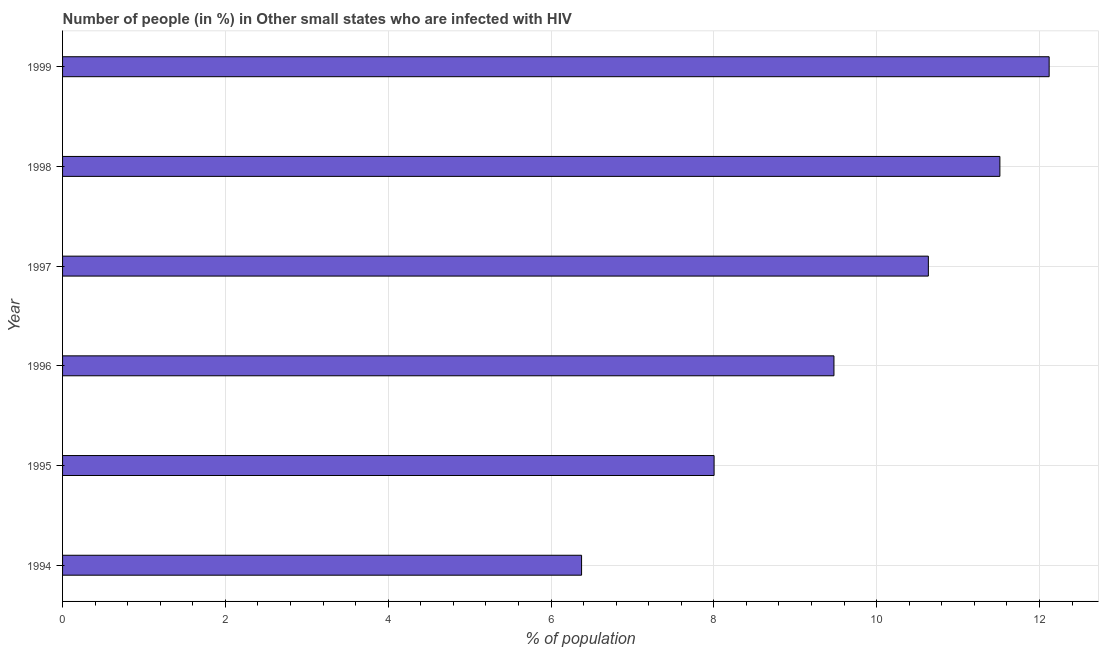Does the graph contain any zero values?
Provide a short and direct response. No. What is the title of the graph?
Keep it short and to the point. Number of people (in %) in Other small states who are infected with HIV. What is the label or title of the X-axis?
Your response must be concise. % of population. What is the label or title of the Y-axis?
Offer a terse response. Year. What is the number of people infected with hiv in 1996?
Offer a very short reply. 9.48. Across all years, what is the maximum number of people infected with hiv?
Your answer should be very brief. 12.12. Across all years, what is the minimum number of people infected with hiv?
Give a very brief answer. 6.38. In which year was the number of people infected with hiv minimum?
Offer a very short reply. 1994. What is the sum of the number of people infected with hiv?
Your answer should be very brief. 58.12. What is the difference between the number of people infected with hiv in 1996 and 1997?
Keep it short and to the point. -1.16. What is the average number of people infected with hiv per year?
Offer a very short reply. 9.69. What is the median number of people infected with hiv?
Your answer should be very brief. 10.06. What is the ratio of the number of people infected with hiv in 1994 to that in 1999?
Your response must be concise. 0.53. What is the difference between the highest and the second highest number of people infected with hiv?
Offer a very short reply. 0.6. Is the sum of the number of people infected with hiv in 1994 and 1998 greater than the maximum number of people infected with hiv across all years?
Provide a short and direct response. Yes. What is the difference between the highest and the lowest number of people infected with hiv?
Give a very brief answer. 5.74. How many bars are there?
Your answer should be compact. 6. Are all the bars in the graph horizontal?
Provide a short and direct response. Yes. How many years are there in the graph?
Provide a short and direct response. 6. Are the values on the major ticks of X-axis written in scientific E-notation?
Keep it short and to the point. No. What is the % of population of 1994?
Make the answer very short. 6.38. What is the % of population of 1995?
Offer a terse response. 8. What is the % of population of 1996?
Give a very brief answer. 9.48. What is the % of population of 1997?
Offer a terse response. 10.64. What is the % of population in 1998?
Keep it short and to the point. 11.51. What is the % of population in 1999?
Your answer should be compact. 12.12. What is the difference between the % of population in 1994 and 1995?
Your response must be concise. -1.63. What is the difference between the % of population in 1994 and 1996?
Give a very brief answer. -3.1. What is the difference between the % of population in 1994 and 1997?
Make the answer very short. -4.26. What is the difference between the % of population in 1994 and 1998?
Keep it short and to the point. -5.14. What is the difference between the % of population in 1994 and 1999?
Keep it short and to the point. -5.74. What is the difference between the % of population in 1995 and 1996?
Make the answer very short. -1.47. What is the difference between the % of population in 1995 and 1997?
Your response must be concise. -2.63. What is the difference between the % of population in 1995 and 1998?
Your answer should be compact. -3.51. What is the difference between the % of population in 1995 and 1999?
Offer a very short reply. -4.12. What is the difference between the % of population in 1996 and 1997?
Offer a terse response. -1.16. What is the difference between the % of population in 1996 and 1998?
Provide a succinct answer. -2.04. What is the difference between the % of population in 1996 and 1999?
Offer a terse response. -2.64. What is the difference between the % of population in 1997 and 1998?
Your response must be concise. -0.88. What is the difference between the % of population in 1997 and 1999?
Provide a short and direct response. -1.48. What is the difference between the % of population in 1998 and 1999?
Provide a succinct answer. -0.61. What is the ratio of the % of population in 1994 to that in 1995?
Ensure brevity in your answer.  0.8. What is the ratio of the % of population in 1994 to that in 1996?
Give a very brief answer. 0.67. What is the ratio of the % of population in 1994 to that in 1997?
Give a very brief answer. 0.6. What is the ratio of the % of population in 1994 to that in 1998?
Provide a short and direct response. 0.55. What is the ratio of the % of population in 1994 to that in 1999?
Provide a short and direct response. 0.53. What is the ratio of the % of population in 1995 to that in 1996?
Make the answer very short. 0.84. What is the ratio of the % of population in 1995 to that in 1997?
Your answer should be very brief. 0.75. What is the ratio of the % of population in 1995 to that in 1998?
Your response must be concise. 0.69. What is the ratio of the % of population in 1995 to that in 1999?
Provide a short and direct response. 0.66. What is the ratio of the % of population in 1996 to that in 1997?
Make the answer very short. 0.89. What is the ratio of the % of population in 1996 to that in 1998?
Your response must be concise. 0.82. What is the ratio of the % of population in 1996 to that in 1999?
Your answer should be very brief. 0.78. What is the ratio of the % of population in 1997 to that in 1998?
Keep it short and to the point. 0.92. What is the ratio of the % of population in 1997 to that in 1999?
Your response must be concise. 0.88. What is the ratio of the % of population in 1998 to that in 1999?
Ensure brevity in your answer.  0.95. 